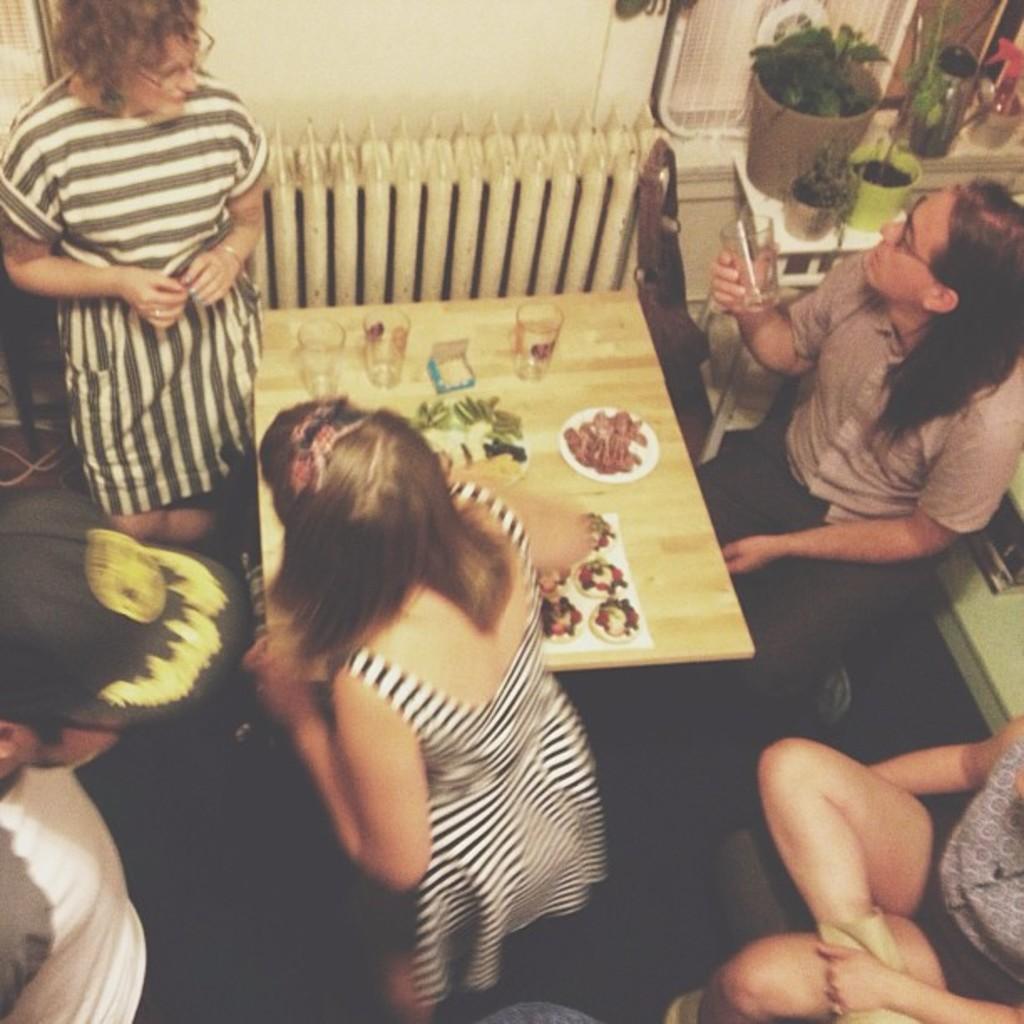Could you give a brief overview of what you see in this image? The image is taken in the room. In the center of the image there is a table. There are glasses, plates and food placed on the table. On the right there are people sitting. In the center there is a lady standing, beside her there is another lady. On the left there is a man. In the background there are plants, glass, bench and a wall. 